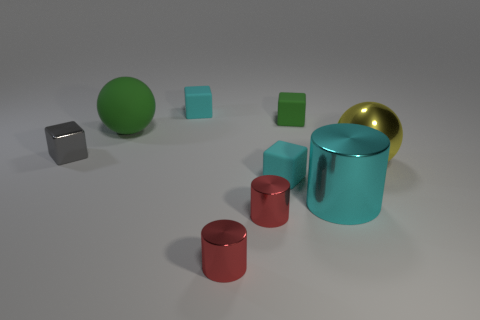What is the shape of the green matte object behind the green thing that is to the left of the green matte cube that is to the right of the small gray shiny object?
Make the answer very short. Cube. There is a yellow sphere that is the same material as the tiny gray object; what is its size?
Your response must be concise. Large. Are there more tiny matte blocks than rubber objects?
Provide a short and direct response. No. What is the material of the green thing that is the same size as the gray metallic cube?
Make the answer very short. Rubber. Is the size of the rubber object that is in front of the gray metal object the same as the big green object?
Make the answer very short. No. What number of balls are either tiny cyan things or gray shiny objects?
Provide a succinct answer. 0. There is a small cyan thing that is in front of the green ball; what material is it?
Your response must be concise. Rubber. Is the number of tiny shiny things less than the number of tiny cyan blocks?
Provide a short and direct response. No. There is a cyan thing that is in front of the big rubber sphere and left of the tiny green object; what size is it?
Offer a very short reply. Small. What size is the green matte ball on the left side of the yellow shiny ball that is to the right of the small matte object in front of the gray shiny block?
Provide a succinct answer. Large. 